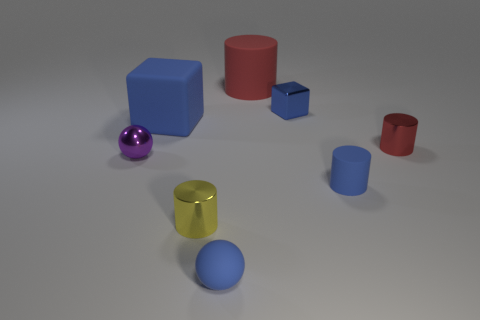Add 2 blue matte blocks. How many objects exist? 10 Subtract all spheres. How many objects are left? 6 Subtract 0 green balls. How many objects are left? 8 Subtract all tiny purple shiny things. Subtract all small rubber objects. How many objects are left? 5 Add 1 big rubber things. How many big rubber things are left? 3 Add 4 purple things. How many purple things exist? 5 